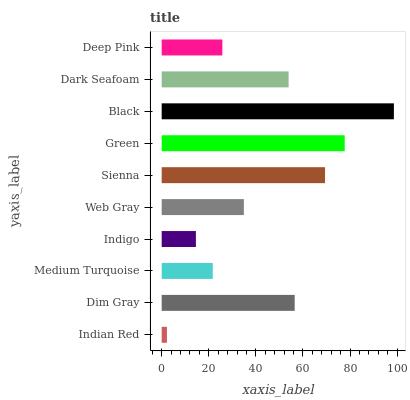Is Indian Red the minimum?
Answer yes or no. Yes. Is Black the maximum?
Answer yes or no. Yes. Is Dim Gray the minimum?
Answer yes or no. No. Is Dim Gray the maximum?
Answer yes or no. No. Is Dim Gray greater than Indian Red?
Answer yes or no. Yes. Is Indian Red less than Dim Gray?
Answer yes or no. Yes. Is Indian Red greater than Dim Gray?
Answer yes or no. No. Is Dim Gray less than Indian Red?
Answer yes or no. No. Is Dark Seafoam the high median?
Answer yes or no. Yes. Is Web Gray the low median?
Answer yes or no. Yes. Is Sienna the high median?
Answer yes or no. No. Is Indigo the low median?
Answer yes or no. No. 